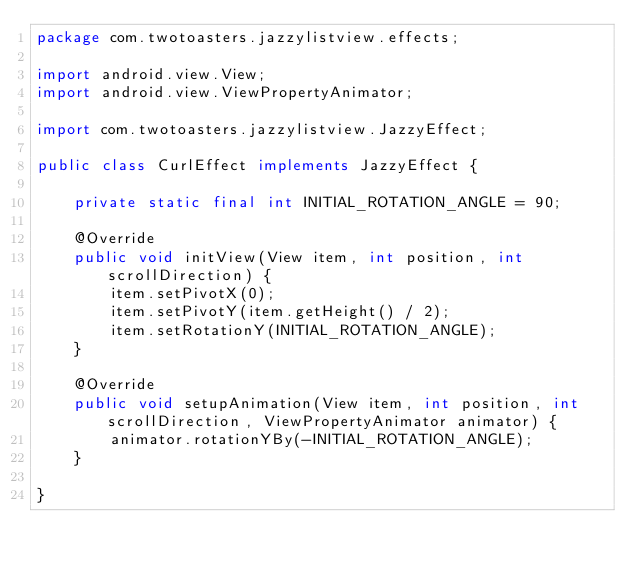<code> <loc_0><loc_0><loc_500><loc_500><_Java_>package com.twotoasters.jazzylistview.effects;

import android.view.View;
import android.view.ViewPropertyAnimator;

import com.twotoasters.jazzylistview.JazzyEffect;

public class CurlEffect implements JazzyEffect {

    private static final int INITIAL_ROTATION_ANGLE = 90;

    @Override
    public void initView(View item, int position, int scrollDirection) {
        item.setPivotX(0);
        item.setPivotY(item.getHeight() / 2);
        item.setRotationY(INITIAL_ROTATION_ANGLE);
    }

    @Override
    public void setupAnimation(View item, int position, int scrollDirection, ViewPropertyAnimator animator) {
        animator.rotationYBy(-INITIAL_ROTATION_ANGLE);
    }

}
</code> 